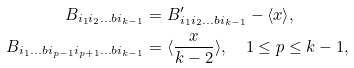<formula> <loc_0><loc_0><loc_500><loc_500>B _ { i _ { 1 } i _ { 2 } \dots b i _ { k - 1 } } & = B ^ { \prime } _ { i _ { 1 } i _ { 2 } \dots b i _ { k - 1 } } - \langle x \rangle , \\ B _ { i _ { 1 } \dots b i _ { p - 1 } i _ { p + 1 } \dots b i _ { k - 1 } } & = \langle \frac { x } { k - 2 } \rangle , \quad 1 \leq p \leq k - 1 ,</formula> 